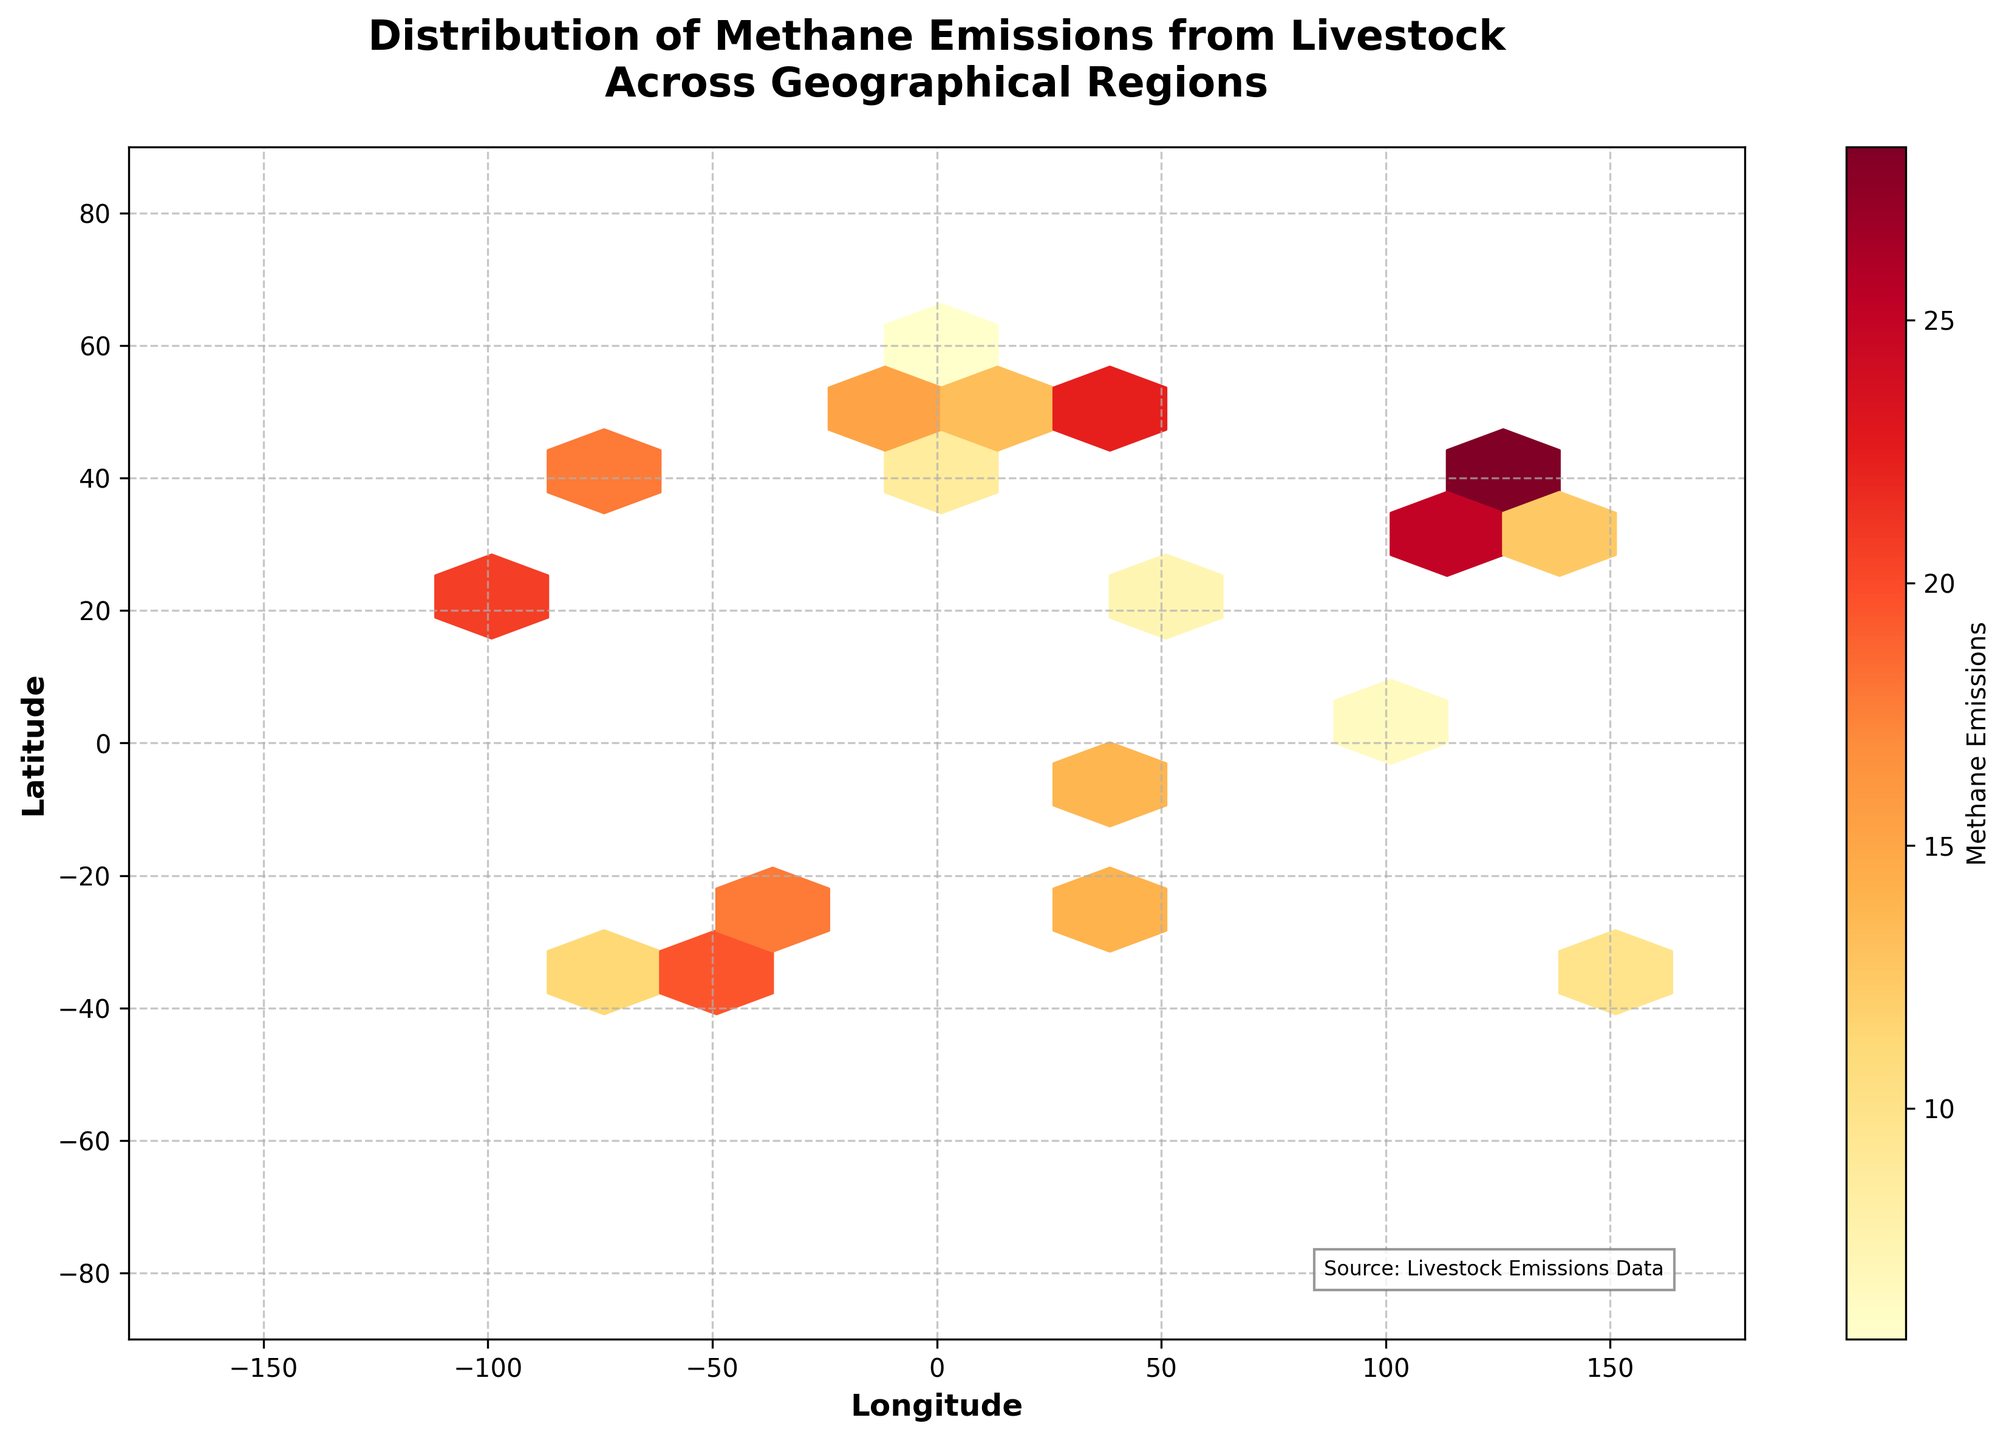What's the title of the figure? The title is clearly displayed at the top of the figure. It reads, "Distribution of Methane Emissions from Livestock Across Geographical Regions."
Answer: Distribution of Methane Emissions from Livestock Across Geographical Regions What is the color range used in the hexbin plot? The color range represents methane emissions and goes from light yellow to dark red. These colors indicate lower to higher emissions, respectively.
Answer: Light yellow to dark red How is the methane emission information conveyed in the plot? The methane emission values are conveyed through the color intensity of the hexagons. The color bar on the right shows the gradient from lower to higher emissions.
Answer: Color intensity What is the longitude range shown in the plot? The axis label and tick marks indicate the longitude range, which goes from -180 to 180.
Answer: -180 to 180 What is the latitude range shown in the plot? The axis label and tick marks indicate the latitude range, which goes from -90 to 90.
Answer: -90 to 90 Which geographical region has the highest methane emissions? By looking at the color intensity, we can see that the hexagon around (39.9042, 116.4074), representing Beijing, China, is the darkest, indicating the highest emissions.
Answer: Beijing, China Which geographical region has the lowest methane emissions? The hexbin over (59.9139, 10.7522), representing Oslo, Norway, is among the lightest colored hexagons, indicating the lowest emissions.
Answer: Oslo, Norway How do methane emissions in New York (40.7128, -74.0060) compare to those in London (51.5074, -0.1278)? New York's hexagon is darker than London's on the plot, indicating that New York has higher methane emissions.
Answer: New York has higher emissions What is the range of methane emissions shown in the color bar? The color bar on the right displays the range of methane emissions from approximately 5.6 to 28.3.
Answer: 5.6 to 28.3 What is the trend in methane emissions as you move from high to low latitudes? Analyzing the color changes from extremes of latitudes, there is no clear consistent trend visible in the plot for emissions by latitude alone; emissions appear to be more region-specific rather than latitude-dependent.
Answer: No consistent trend 